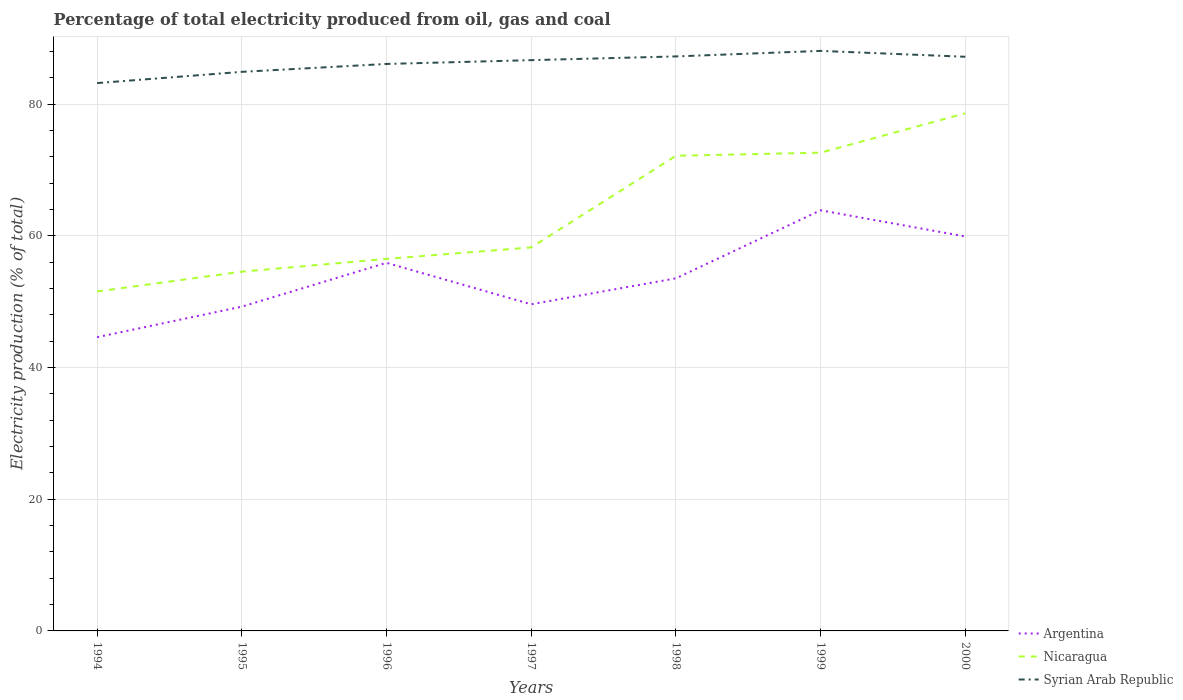How many different coloured lines are there?
Your answer should be compact. 3. Does the line corresponding to Syrian Arab Republic intersect with the line corresponding to Nicaragua?
Your response must be concise. No. Across all years, what is the maximum electricity production in in Nicaragua?
Provide a short and direct response. 51.55. What is the total electricity production in in Argentina in the graph?
Make the answer very short. 6.29. What is the difference between the highest and the second highest electricity production in in Argentina?
Provide a succinct answer. 19.27. Where does the legend appear in the graph?
Keep it short and to the point. Bottom right. How many legend labels are there?
Make the answer very short. 3. What is the title of the graph?
Provide a succinct answer. Percentage of total electricity produced from oil, gas and coal. Does "Other small states" appear as one of the legend labels in the graph?
Provide a succinct answer. No. What is the label or title of the Y-axis?
Ensure brevity in your answer.  Electricity production (% of total). What is the Electricity production (% of total) of Argentina in 1994?
Offer a terse response. 44.6. What is the Electricity production (% of total) in Nicaragua in 1994?
Keep it short and to the point. 51.55. What is the Electricity production (% of total) in Syrian Arab Republic in 1994?
Give a very brief answer. 83.19. What is the Electricity production (% of total) in Argentina in 1995?
Your answer should be compact. 49.24. What is the Electricity production (% of total) in Nicaragua in 1995?
Offer a terse response. 54.56. What is the Electricity production (% of total) of Syrian Arab Republic in 1995?
Ensure brevity in your answer.  84.9. What is the Electricity production (% of total) in Argentina in 1996?
Your response must be concise. 55.9. What is the Electricity production (% of total) in Nicaragua in 1996?
Offer a terse response. 56.5. What is the Electricity production (% of total) in Syrian Arab Republic in 1996?
Your response must be concise. 86.1. What is the Electricity production (% of total) in Argentina in 1997?
Offer a terse response. 49.6. What is the Electricity production (% of total) of Nicaragua in 1997?
Keep it short and to the point. 58.24. What is the Electricity production (% of total) of Syrian Arab Republic in 1997?
Offer a terse response. 86.67. What is the Electricity production (% of total) of Argentina in 1998?
Ensure brevity in your answer.  53.54. What is the Electricity production (% of total) in Nicaragua in 1998?
Make the answer very short. 72.15. What is the Electricity production (% of total) of Syrian Arab Republic in 1998?
Provide a short and direct response. 87.24. What is the Electricity production (% of total) of Argentina in 1999?
Offer a terse response. 63.87. What is the Electricity production (% of total) in Nicaragua in 1999?
Offer a terse response. 72.62. What is the Electricity production (% of total) of Syrian Arab Republic in 1999?
Offer a terse response. 88.08. What is the Electricity production (% of total) of Argentina in 2000?
Offer a terse response. 59.89. What is the Electricity production (% of total) in Nicaragua in 2000?
Your answer should be very brief. 78.6. What is the Electricity production (% of total) of Syrian Arab Republic in 2000?
Ensure brevity in your answer.  87.19. Across all years, what is the maximum Electricity production (% of total) in Argentina?
Give a very brief answer. 63.87. Across all years, what is the maximum Electricity production (% of total) of Nicaragua?
Provide a succinct answer. 78.6. Across all years, what is the maximum Electricity production (% of total) in Syrian Arab Republic?
Provide a short and direct response. 88.08. Across all years, what is the minimum Electricity production (% of total) of Argentina?
Your answer should be compact. 44.6. Across all years, what is the minimum Electricity production (% of total) in Nicaragua?
Provide a short and direct response. 51.55. Across all years, what is the minimum Electricity production (% of total) of Syrian Arab Republic?
Keep it short and to the point. 83.19. What is the total Electricity production (% of total) of Argentina in the graph?
Make the answer very short. 376.65. What is the total Electricity production (% of total) of Nicaragua in the graph?
Your answer should be very brief. 444.22. What is the total Electricity production (% of total) in Syrian Arab Republic in the graph?
Your response must be concise. 603.37. What is the difference between the Electricity production (% of total) of Argentina in 1994 and that in 1995?
Your answer should be compact. -4.64. What is the difference between the Electricity production (% of total) of Nicaragua in 1994 and that in 1995?
Provide a succinct answer. -3.01. What is the difference between the Electricity production (% of total) in Syrian Arab Republic in 1994 and that in 1995?
Provide a succinct answer. -1.71. What is the difference between the Electricity production (% of total) of Argentina in 1994 and that in 1996?
Offer a very short reply. -11.29. What is the difference between the Electricity production (% of total) of Nicaragua in 1994 and that in 1996?
Your answer should be very brief. -4.95. What is the difference between the Electricity production (% of total) in Syrian Arab Republic in 1994 and that in 1996?
Your answer should be compact. -2.91. What is the difference between the Electricity production (% of total) of Argentina in 1994 and that in 1997?
Your answer should be very brief. -5. What is the difference between the Electricity production (% of total) of Nicaragua in 1994 and that in 1997?
Make the answer very short. -6.69. What is the difference between the Electricity production (% of total) in Syrian Arab Republic in 1994 and that in 1997?
Your answer should be very brief. -3.48. What is the difference between the Electricity production (% of total) in Argentina in 1994 and that in 1998?
Your answer should be very brief. -8.94. What is the difference between the Electricity production (% of total) in Nicaragua in 1994 and that in 1998?
Your answer should be very brief. -20.61. What is the difference between the Electricity production (% of total) of Syrian Arab Republic in 1994 and that in 1998?
Make the answer very short. -4.05. What is the difference between the Electricity production (% of total) in Argentina in 1994 and that in 1999?
Ensure brevity in your answer.  -19.27. What is the difference between the Electricity production (% of total) in Nicaragua in 1994 and that in 1999?
Your answer should be very brief. -21.08. What is the difference between the Electricity production (% of total) of Syrian Arab Republic in 1994 and that in 1999?
Keep it short and to the point. -4.89. What is the difference between the Electricity production (% of total) of Argentina in 1994 and that in 2000?
Your answer should be very brief. -15.29. What is the difference between the Electricity production (% of total) in Nicaragua in 1994 and that in 2000?
Provide a succinct answer. -27.06. What is the difference between the Electricity production (% of total) of Syrian Arab Republic in 1994 and that in 2000?
Offer a very short reply. -4. What is the difference between the Electricity production (% of total) in Argentina in 1995 and that in 1996?
Offer a terse response. -6.65. What is the difference between the Electricity production (% of total) in Nicaragua in 1995 and that in 1996?
Your answer should be very brief. -1.94. What is the difference between the Electricity production (% of total) of Syrian Arab Republic in 1995 and that in 1996?
Make the answer very short. -1.2. What is the difference between the Electricity production (% of total) in Argentina in 1995 and that in 1997?
Ensure brevity in your answer.  -0.36. What is the difference between the Electricity production (% of total) of Nicaragua in 1995 and that in 1997?
Make the answer very short. -3.68. What is the difference between the Electricity production (% of total) in Syrian Arab Republic in 1995 and that in 1997?
Provide a succinct answer. -1.78. What is the difference between the Electricity production (% of total) of Argentina in 1995 and that in 1998?
Your answer should be compact. -4.3. What is the difference between the Electricity production (% of total) of Nicaragua in 1995 and that in 1998?
Offer a very short reply. -17.6. What is the difference between the Electricity production (% of total) of Syrian Arab Republic in 1995 and that in 1998?
Keep it short and to the point. -2.34. What is the difference between the Electricity production (% of total) of Argentina in 1995 and that in 1999?
Provide a short and direct response. -14.63. What is the difference between the Electricity production (% of total) in Nicaragua in 1995 and that in 1999?
Your answer should be compact. -18.07. What is the difference between the Electricity production (% of total) in Syrian Arab Republic in 1995 and that in 1999?
Offer a very short reply. -3.18. What is the difference between the Electricity production (% of total) of Argentina in 1995 and that in 2000?
Make the answer very short. -10.65. What is the difference between the Electricity production (% of total) of Nicaragua in 1995 and that in 2000?
Your answer should be very brief. -24.05. What is the difference between the Electricity production (% of total) in Syrian Arab Republic in 1995 and that in 2000?
Give a very brief answer. -2.29. What is the difference between the Electricity production (% of total) in Argentina in 1996 and that in 1997?
Your answer should be compact. 6.29. What is the difference between the Electricity production (% of total) of Nicaragua in 1996 and that in 1997?
Offer a terse response. -1.74. What is the difference between the Electricity production (% of total) in Syrian Arab Republic in 1996 and that in 1997?
Your answer should be very brief. -0.58. What is the difference between the Electricity production (% of total) of Argentina in 1996 and that in 1998?
Provide a succinct answer. 2.36. What is the difference between the Electricity production (% of total) in Nicaragua in 1996 and that in 1998?
Offer a terse response. -15.66. What is the difference between the Electricity production (% of total) of Syrian Arab Republic in 1996 and that in 1998?
Keep it short and to the point. -1.14. What is the difference between the Electricity production (% of total) in Argentina in 1996 and that in 1999?
Ensure brevity in your answer.  -7.98. What is the difference between the Electricity production (% of total) in Nicaragua in 1996 and that in 1999?
Ensure brevity in your answer.  -16.12. What is the difference between the Electricity production (% of total) of Syrian Arab Republic in 1996 and that in 1999?
Give a very brief answer. -1.98. What is the difference between the Electricity production (% of total) of Argentina in 1996 and that in 2000?
Offer a very short reply. -4. What is the difference between the Electricity production (% of total) of Nicaragua in 1996 and that in 2000?
Your answer should be compact. -22.11. What is the difference between the Electricity production (% of total) of Syrian Arab Republic in 1996 and that in 2000?
Give a very brief answer. -1.09. What is the difference between the Electricity production (% of total) in Argentina in 1997 and that in 1998?
Make the answer very short. -3.94. What is the difference between the Electricity production (% of total) of Nicaragua in 1997 and that in 1998?
Ensure brevity in your answer.  -13.91. What is the difference between the Electricity production (% of total) of Syrian Arab Republic in 1997 and that in 1998?
Your answer should be compact. -0.56. What is the difference between the Electricity production (% of total) in Argentina in 1997 and that in 1999?
Ensure brevity in your answer.  -14.27. What is the difference between the Electricity production (% of total) of Nicaragua in 1997 and that in 1999?
Provide a short and direct response. -14.38. What is the difference between the Electricity production (% of total) in Syrian Arab Republic in 1997 and that in 1999?
Keep it short and to the point. -1.41. What is the difference between the Electricity production (% of total) of Argentina in 1997 and that in 2000?
Your answer should be very brief. -10.29. What is the difference between the Electricity production (% of total) in Nicaragua in 1997 and that in 2000?
Your answer should be very brief. -20.37. What is the difference between the Electricity production (% of total) of Syrian Arab Republic in 1997 and that in 2000?
Give a very brief answer. -0.51. What is the difference between the Electricity production (% of total) in Argentina in 1998 and that in 1999?
Offer a terse response. -10.33. What is the difference between the Electricity production (% of total) in Nicaragua in 1998 and that in 1999?
Give a very brief answer. -0.47. What is the difference between the Electricity production (% of total) in Syrian Arab Republic in 1998 and that in 1999?
Ensure brevity in your answer.  -0.84. What is the difference between the Electricity production (% of total) of Argentina in 1998 and that in 2000?
Your response must be concise. -6.35. What is the difference between the Electricity production (% of total) of Nicaragua in 1998 and that in 2000?
Offer a very short reply. -6.45. What is the difference between the Electricity production (% of total) of Syrian Arab Republic in 1998 and that in 2000?
Provide a short and direct response. 0.05. What is the difference between the Electricity production (% of total) in Argentina in 1999 and that in 2000?
Ensure brevity in your answer.  3.98. What is the difference between the Electricity production (% of total) in Nicaragua in 1999 and that in 2000?
Your answer should be very brief. -5.98. What is the difference between the Electricity production (% of total) of Syrian Arab Republic in 1999 and that in 2000?
Your answer should be compact. 0.89. What is the difference between the Electricity production (% of total) of Argentina in 1994 and the Electricity production (% of total) of Nicaragua in 1995?
Offer a terse response. -9.95. What is the difference between the Electricity production (% of total) of Argentina in 1994 and the Electricity production (% of total) of Syrian Arab Republic in 1995?
Provide a succinct answer. -40.3. What is the difference between the Electricity production (% of total) of Nicaragua in 1994 and the Electricity production (% of total) of Syrian Arab Republic in 1995?
Provide a succinct answer. -33.35. What is the difference between the Electricity production (% of total) of Argentina in 1994 and the Electricity production (% of total) of Nicaragua in 1996?
Offer a terse response. -11.9. What is the difference between the Electricity production (% of total) of Argentina in 1994 and the Electricity production (% of total) of Syrian Arab Republic in 1996?
Make the answer very short. -41.49. What is the difference between the Electricity production (% of total) of Nicaragua in 1994 and the Electricity production (% of total) of Syrian Arab Republic in 1996?
Your response must be concise. -34.55. What is the difference between the Electricity production (% of total) in Argentina in 1994 and the Electricity production (% of total) in Nicaragua in 1997?
Your response must be concise. -13.64. What is the difference between the Electricity production (% of total) of Argentina in 1994 and the Electricity production (% of total) of Syrian Arab Republic in 1997?
Provide a succinct answer. -42.07. What is the difference between the Electricity production (% of total) of Nicaragua in 1994 and the Electricity production (% of total) of Syrian Arab Republic in 1997?
Keep it short and to the point. -35.13. What is the difference between the Electricity production (% of total) of Argentina in 1994 and the Electricity production (% of total) of Nicaragua in 1998?
Your answer should be compact. -27.55. What is the difference between the Electricity production (% of total) of Argentina in 1994 and the Electricity production (% of total) of Syrian Arab Republic in 1998?
Give a very brief answer. -42.64. What is the difference between the Electricity production (% of total) in Nicaragua in 1994 and the Electricity production (% of total) in Syrian Arab Republic in 1998?
Ensure brevity in your answer.  -35.69. What is the difference between the Electricity production (% of total) of Argentina in 1994 and the Electricity production (% of total) of Nicaragua in 1999?
Offer a terse response. -28.02. What is the difference between the Electricity production (% of total) of Argentina in 1994 and the Electricity production (% of total) of Syrian Arab Republic in 1999?
Provide a succinct answer. -43.48. What is the difference between the Electricity production (% of total) in Nicaragua in 1994 and the Electricity production (% of total) in Syrian Arab Republic in 1999?
Provide a short and direct response. -36.53. What is the difference between the Electricity production (% of total) of Argentina in 1994 and the Electricity production (% of total) of Nicaragua in 2000?
Give a very brief answer. -34. What is the difference between the Electricity production (% of total) of Argentina in 1994 and the Electricity production (% of total) of Syrian Arab Republic in 2000?
Keep it short and to the point. -42.58. What is the difference between the Electricity production (% of total) in Nicaragua in 1994 and the Electricity production (% of total) in Syrian Arab Republic in 2000?
Your response must be concise. -35.64. What is the difference between the Electricity production (% of total) in Argentina in 1995 and the Electricity production (% of total) in Nicaragua in 1996?
Your response must be concise. -7.25. What is the difference between the Electricity production (% of total) in Argentina in 1995 and the Electricity production (% of total) in Syrian Arab Republic in 1996?
Your response must be concise. -36.85. What is the difference between the Electricity production (% of total) in Nicaragua in 1995 and the Electricity production (% of total) in Syrian Arab Republic in 1996?
Your response must be concise. -31.54. What is the difference between the Electricity production (% of total) of Argentina in 1995 and the Electricity production (% of total) of Nicaragua in 1997?
Offer a very short reply. -9. What is the difference between the Electricity production (% of total) in Argentina in 1995 and the Electricity production (% of total) in Syrian Arab Republic in 1997?
Make the answer very short. -37.43. What is the difference between the Electricity production (% of total) of Nicaragua in 1995 and the Electricity production (% of total) of Syrian Arab Republic in 1997?
Your response must be concise. -32.12. What is the difference between the Electricity production (% of total) of Argentina in 1995 and the Electricity production (% of total) of Nicaragua in 1998?
Your response must be concise. -22.91. What is the difference between the Electricity production (% of total) in Argentina in 1995 and the Electricity production (% of total) in Syrian Arab Republic in 1998?
Offer a terse response. -38. What is the difference between the Electricity production (% of total) of Nicaragua in 1995 and the Electricity production (% of total) of Syrian Arab Republic in 1998?
Provide a succinct answer. -32.68. What is the difference between the Electricity production (% of total) in Argentina in 1995 and the Electricity production (% of total) in Nicaragua in 1999?
Your response must be concise. -23.38. What is the difference between the Electricity production (% of total) of Argentina in 1995 and the Electricity production (% of total) of Syrian Arab Republic in 1999?
Keep it short and to the point. -38.84. What is the difference between the Electricity production (% of total) in Nicaragua in 1995 and the Electricity production (% of total) in Syrian Arab Republic in 1999?
Your answer should be compact. -33.52. What is the difference between the Electricity production (% of total) in Argentina in 1995 and the Electricity production (% of total) in Nicaragua in 2000?
Offer a very short reply. -29.36. What is the difference between the Electricity production (% of total) in Argentina in 1995 and the Electricity production (% of total) in Syrian Arab Republic in 2000?
Your response must be concise. -37.94. What is the difference between the Electricity production (% of total) in Nicaragua in 1995 and the Electricity production (% of total) in Syrian Arab Republic in 2000?
Offer a terse response. -32.63. What is the difference between the Electricity production (% of total) in Argentina in 1996 and the Electricity production (% of total) in Nicaragua in 1997?
Keep it short and to the point. -2.34. What is the difference between the Electricity production (% of total) in Argentina in 1996 and the Electricity production (% of total) in Syrian Arab Republic in 1997?
Ensure brevity in your answer.  -30.78. What is the difference between the Electricity production (% of total) of Nicaragua in 1996 and the Electricity production (% of total) of Syrian Arab Republic in 1997?
Make the answer very short. -30.18. What is the difference between the Electricity production (% of total) in Argentina in 1996 and the Electricity production (% of total) in Nicaragua in 1998?
Provide a succinct answer. -16.26. What is the difference between the Electricity production (% of total) of Argentina in 1996 and the Electricity production (% of total) of Syrian Arab Republic in 1998?
Offer a terse response. -31.34. What is the difference between the Electricity production (% of total) of Nicaragua in 1996 and the Electricity production (% of total) of Syrian Arab Republic in 1998?
Make the answer very short. -30.74. What is the difference between the Electricity production (% of total) of Argentina in 1996 and the Electricity production (% of total) of Nicaragua in 1999?
Offer a terse response. -16.73. What is the difference between the Electricity production (% of total) of Argentina in 1996 and the Electricity production (% of total) of Syrian Arab Republic in 1999?
Keep it short and to the point. -32.18. What is the difference between the Electricity production (% of total) in Nicaragua in 1996 and the Electricity production (% of total) in Syrian Arab Republic in 1999?
Your response must be concise. -31.58. What is the difference between the Electricity production (% of total) of Argentina in 1996 and the Electricity production (% of total) of Nicaragua in 2000?
Your answer should be compact. -22.71. What is the difference between the Electricity production (% of total) of Argentina in 1996 and the Electricity production (% of total) of Syrian Arab Republic in 2000?
Provide a succinct answer. -31.29. What is the difference between the Electricity production (% of total) in Nicaragua in 1996 and the Electricity production (% of total) in Syrian Arab Republic in 2000?
Provide a succinct answer. -30.69. What is the difference between the Electricity production (% of total) of Argentina in 1997 and the Electricity production (% of total) of Nicaragua in 1998?
Ensure brevity in your answer.  -22.55. What is the difference between the Electricity production (% of total) in Argentina in 1997 and the Electricity production (% of total) in Syrian Arab Republic in 1998?
Give a very brief answer. -37.64. What is the difference between the Electricity production (% of total) in Nicaragua in 1997 and the Electricity production (% of total) in Syrian Arab Republic in 1998?
Your answer should be very brief. -29. What is the difference between the Electricity production (% of total) of Argentina in 1997 and the Electricity production (% of total) of Nicaragua in 1999?
Make the answer very short. -23.02. What is the difference between the Electricity production (% of total) of Argentina in 1997 and the Electricity production (% of total) of Syrian Arab Republic in 1999?
Provide a succinct answer. -38.48. What is the difference between the Electricity production (% of total) of Nicaragua in 1997 and the Electricity production (% of total) of Syrian Arab Republic in 1999?
Ensure brevity in your answer.  -29.84. What is the difference between the Electricity production (% of total) in Argentina in 1997 and the Electricity production (% of total) in Nicaragua in 2000?
Ensure brevity in your answer.  -29. What is the difference between the Electricity production (% of total) in Argentina in 1997 and the Electricity production (% of total) in Syrian Arab Republic in 2000?
Give a very brief answer. -37.59. What is the difference between the Electricity production (% of total) in Nicaragua in 1997 and the Electricity production (% of total) in Syrian Arab Republic in 2000?
Your response must be concise. -28.95. What is the difference between the Electricity production (% of total) in Argentina in 1998 and the Electricity production (% of total) in Nicaragua in 1999?
Your answer should be very brief. -19.08. What is the difference between the Electricity production (% of total) of Argentina in 1998 and the Electricity production (% of total) of Syrian Arab Republic in 1999?
Make the answer very short. -34.54. What is the difference between the Electricity production (% of total) of Nicaragua in 1998 and the Electricity production (% of total) of Syrian Arab Republic in 1999?
Provide a succinct answer. -15.93. What is the difference between the Electricity production (% of total) in Argentina in 1998 and the Electricity production (% of total) in Nicaragua in 2000?
Your answer should be compact. -25.06. What is the difference between the Electricity production (% of total) in Argentina in 1998 and the Electricity production (% of total) in Syrian Arab Republic in 2000?
Your answer should be compact. -33.65. What is the difference between the Electricity production (% of total) in Nicaragua in 1998 and the Electricity production (% of total) in Syrian Arab Republic in 2000?
Your response must be concise. -15.03. What is the difference between the Electricity production (% of total) in Argentina in 1999 and the Electricity production (% of total) in Nicaragua in 2000?
Offer a very short reply. -14.73. What is the difference between the Electricity production (% of total) of Argentina in 1999 and the Electricity production (% of total) of Syrian Arab Republic in 2000?
Make the answer very short. -23.31. What is the difference between the Electricity production (% of total) of Nicaragua in 1999 and the Electricity production (% of total) of Syrian Arab Republic in 2000?
Offer a terse response. -14.56. What is the average Electricity production (% of total) of Argentina per year?
Keep it short and to the point. 53.81. What is the average Electricity production (% of total) of Nicaragua per year?
Provide a short and direct response. 63.46. What is the average Electricity production (% of total) of Syrian Arab Republic per year?
Ensure brevity in your answer.  86.2. In the year 1994, what is the difference between the Electricity production (% of total) in Argentina and Electricity production (% of total) in Nicaragua?
Ensure brevity in your answer.  -6.94. In the year 1994, what is the difference between the Electricity production (% of total) in Argentina and Electricity production (% of total) in Syrian Arab Republic?
Your answer should be very brief. -38.59. In the year 1994, what is the difference between the Electricity production (% of total) of Nicaragua and Electricity production (% of total) of Syrian Arab Republic?
Make the answer very short. -31.64. In the year 1995, what is the difference between the Electricity production (% of total) of Argentina and Electricity production (% of total) of Nicaragua?
Make the answer very short. -5.31. In the year 1995, what is the difference between the Electricity production (% of total) in Argentina and Electricity production (% of total) in Syrian Arab Republic?
Your response must be concise. -35.66. In the year 1995, what is the difference between the Electricity production (% of total) of Nicaragua and Electricity production (% of total) of Syrian Arab Republic?
Ensure brevity in your answer.  -30.34. In the year 1996, what is the difference between the Electricity production (% of total) in Argentina and Electricity production (% of total) in Nicaragua?
Make the answer very short. -0.6. In the year 1996, what is the difference between the Electricity production (% of total) of Argentina and Electricity production (% of total) of Syrian Arab Republic?
Your response must be concise. -30.2. In the year 1996, what is the difference between the Electricity production (% of total) in Nicaragua and Electricity production (% of total) in Syrian Arab Republic?
Make the answer very short. -29.6. In the year 1997, what is the difference between the Electricity production (% of total) of Argentina and Electricity production (% of total) of Nicaragua?
Provide a short and direct response. -8.64. In the year 1997, what is the difference between the Electricity production (% of total) of Argentina and Electricity production (% of total) of Syrian Arab Republic?
Offer a very short reply. -37.07. In the year 1997, what is the difference between the Electricity production (% of total) in Nicaragua and Electricity production (% of total) in Syrian Arab Republic?
Make the answer very short. -28.44. In the year 1998, what is the difference between the Electricity production (% of total) in Argentina and Electricity production (% of total) in Nicaragua?
Offer a very short reply. -18.61. In the year 1998, what is the difference between the Electricity production (% of total) of Argentina and Electricity production (% of total) of Syrian Arab Republic?
Offer a terse response. -33.7. In the year 1998, what is the difference between the Electricity production (% of total) in Nicaragua and Electricity production (% of total) in Syrian Arab Republic?
Provide a succinct answer. -15.09. In the year 1999, what is the difference between the Electricity production (% of total) in Argentina and Electricity production (% of total) in Nicaragua?
Offer a very short reply. -8.75. In the year 1999, what is the difference between the Electricity production (% of total) of Argentina and Electricity production (% of total) of Syrian Arab Republic?
Offer a terse response. -24.21. In the year 1999, what is the difference between the Electricity production (% of total) in Nicaragua and Electricity production (% of total) in Syrian Arab Republic?
Provide a succinct answer. -15.46. In the year 2000, what is the difference between the Electricity production (% of total) in Argentina and Electricity production (% of total) in Nicaragua?
Give a very brief answer. -18.71. In the year 2000, what is the difference between the Electricity production (% of total) in Argentina and Electricity production (% of total) in Syrian Arab Republic?
Your answer should be compact. -27.29. In the year 2000, what is the difference between the Electricity production (% of total) of Nicaragua and Electricity production (% of total) of Syrian Arab Republic?
Offer a very short reply. -8.58. What is the ratio of the Electricity production (% of total) in Argentina in 1994 to that in 1995?
Provide a short and direct response. 0.91. What is the ratio of the Electricity production (% of total) of Nicaragua in 1994 to that in 1995?
Offer a terse response. 0.94. What is the ratio of the Electricity production (% of total) of Syrian Arab Republic in 1994 to that in 1995?
Your answer should be very brief. 0.98. What is the ratio of the Electricity production (% of total) in Argentina in 1994 to that in 1996?
Give a very brief answer. 0.8. What is the ratio of the Electricity production (% of total) of Nicaragua in 1994 to that in 1996?
Keep it short and to the point. 0.91. What is the ratio of the Electricity production (% of total) of Syrian Arab Republic in 1994 to that in 1996?
Your response must be concise. 0.97. What is the ratio of the Electricity production (% of total) of Argentina in 1994 to that in 1997?
Your response must be concise. 0.9. What is the ratio of the Electricity production (% of total) of Nicaragua in 1994 to that in 1997?
Make the answer very short. 0.89. What is the ratio of the Electricity production (% of total) in Syrian Arab Republic in 1994 to that in 1997?
Your response must be concise. 0.96. What is the ratio of the Electricity production (% of total) of Argentina in 1994 to that in 1998?
Keep it short and to the point. 0.83. What is the ratio of the Electricity production (% of total) of Nicaragua in 1994 to that in 1998?
Your answer should be very brief. 0.71. What is the ratio of the Electricity production (% of total) in Syrian Arab Republic in 1994 to that in 1998?
Your answer should be compact. 0.95. What is the ratio of the Electricity production (% of total) of Argentina in 1994 to that in 1999?
Your answer should be very brief. 0.7. What is the ratio of the Electricity production (% of total) in Nicaragua in 1994 to that in 1999?
Give a very brief answer. 0.71. What is the ratio of the Electricity production (% of total) in Syrian Arab Republic in 1994 to that in 1999?
Give a very brief answer. 0.94. What is the ratio of the Electricity production (% of total) of Argentina in 1994 to that in 2000?
Ensure brevity in your answer.  0.74. What is the ratio of the Electricity production (% of total) in Nicaragua in 1994 to that in 2000?
Make the answer very short. 0.66. What is the ratio of the Electricity production (% of total) in Syrian Arab Republic in 1994 to that in 2000?
Your answer should be compact. 0.95. What is the ratio of the Electricity production (% of total) in Argentina in 1995 to that in 1996?
Your answer should be very brief. 0.88. What is the ratio of the Electricity production (% of total) of Nicaragua in 1995 to that in 1996?
Provide a succinct answer. 0.97. What is the ratio of the Electricity production (% of total) in Syrian Arab Republic in 1995 to that in 1996?
Ensure brevity in your answer.  0.99. What is the ratio of the Electricity production (% of total) of Argentina in 1995 to that in 1997?
Keep it short and to the point. 0.99. What is the ratio of the Electricity production (% of total) of Nicaragua in 1995 to that in 1997?
Offer a very short reply. 0.94. What is the ratio of the Electricity production (% of total) of Syrian Arab Republic in 1995 to that in 1997?
Your response must be concise. 0.98. What is the ratio of the Electricity production (% of total) of Argentina in 1995 to that in 1998?
Your answer should be compact. 0.92. What is the ratio of the Electricity production (% of total) in Nicaragua in 1995 to that in 1998?
Offer a terse response. 0.76. What is the ratio of the Electricity production (% of total) in Syrian Arab Republic in 1995 to that in 1998?
Provide a short and direct response. 0.97. What is the ratio of the Electricity production (% of total) of Argentina in 1995 to that in 1999?
Your answer should be very brief. 0.77. What is the ratio of the Electricity production (% of total) of Nicaragua in 1995 to that in 1999?
Provide a succinct answer. 0.75. What is the ratio of the Electricity production (% of total) in Syrian Arab Republic in 1995 to that in 1999?
Ensure brevity in your answer.  0.96. What is the ratio of the Electricity production (% of total) in Argentina in 1995 to that in 2000?
Your answer should be compact. 0.82. What is the ratio of the Electricity production (% of total) in Nicaragua in 1995 to that in 2000?
Provide a succinct answer. 0.69. What is the ratio of the Electricity production (% of total) in Syrian Arab Republic in 1995 to that in 2000?
Ensure brevity in your answer.  0.97. What is the ratio of the Electricity production (% of total) of Argentina in 1996 to that in 1997?
Your response must be concise. 1.13. What is the ratio of the Electricity production (% of total) in Nicaragua in 1996 to that in 1997?
Offer a very short reply. 0.97. What is the ratio of the Electricity production (% of total) in Syrian Arab Republic in 1996 to that in 1997?
Offer a very short reply. 0.99. What is the ratio of the Electricity production (% of total) of Argentina in 1996 to that in 1998?
Ensure brevity in your answer.  1.04. What is the ratio of the Electricity production (% of total) of Nicaragua in 1996 to that in 1998?
Provide a succinct answer. 0.78. What is the ratio of the Electricity production (% of total) of Syrian Arab Republic in 1996 to that in 1998?
Offer a terse response. 0.99. What is the ratio of the Electricity production (% of total) in Argentina in 1996 to that in 1999?
Your answer should be very brief. 0.88. What is the ratio of the Electricity production (% of total) of Nicaragua in 1996 to that in 1999?
Give a very brief answer. 0.78. What is the ratio of the Electricity production (% of total) of Syrian Arab Republic in 1996 to that in 1999?
Keep it short and to the point. 0.98. What is the ratio of the Electricity production (% of total) in Argentina in 1996 to that in 2000?
Offer a very short reply. 0.93. What is the ratio of the Electricity production (% of total) of Nicaragua in 1996 to that in 2000?
Give a very brief answer. 0.72. What is the ratio of the Electricity production (% of total) in Syrian Arab Republic in 1996 to that in 2000?
Offer a terse response. 0.99. What is the ratio of the Electricity production (% of total) of Argentina in 1997 to that in 1998?
Provide a succinct answer. 0.93. What is the ratio of the Electricity production (% of total) of Nicaragua in 1997 to that in 1998?
Offer a terse response. 0.81. What is the ratio of the Electricity production (% of total) of Syrian Arab Republic in 1997 to that in 1998?
Keep it short and to the point. 0.99. What is the ratio of the Electricity production (% of total) of Argentina in 1997 to that in 1999?
Ensure brevity in your answer.  0.78. What is the ratio of the Electricity production (% of total) in Nicaragua in 1997 to that in 1999?
Offer a terse response. 0.8. What is the ratio of the Electricity production (% of total) in Syrian Arab Republic in 1997 to that in 1999?
Your answer should be very brief. 0.98. What is the ratio of the Electricity production (% of total) in Argentina in 1997 to that in 2000?
Provide a succinct answer. 0.83. What is the ratio of the Electricity production (% of total) in Nicaragua in 1997 to that in 2000?
Your answer should be compact. 0.74. What is the ratio of the Electricity production (% of total) in Argentina in 1998 to that in 1999?
Your answer should be very brief. 0.84. What is the ratio of the Electricity production (% of total) of Argentina in 1998 to that in 2000?
Your answer should be compact. 0.89. What is the ratio of the Electricity production (% of total) in Nicaragua in 1998 to that in 2000?
Ensure brevity in your answer.  0.92. What is the ratio of the Electricity production (% of total) of Argentina in 1999 to that in 2000?
Give a very brief answer. 1.07. What is the ratio of the Electricity production (% of total) of Nicaragua in 1999 to that in 2000?
Provide a succinct answer. 0.92. What is the ratio of the Electricity production (% of total) of Syrian Arab Republic in 1999 to that in 2000?
Offer a very short reply. 1.01. What is the difference between the highest and the second highest Electricity production (% of total) of Argentina?
Ensure brevity in your answer.  3.98. What is the difference between the highest and the second highest Electricity production (% of total) in Nicaragua?
Provide a succinct answer. 5.98. What is the difference between the highest and the second highest Electricity production (% of total) of Syrian Arab Republic?
Ensure brevity in your answer.  0.84. What is the difference between the highest and the lowest Electricity production (% of total) of Argentina?
Offer a terse response. 19.27. What is the difference between the highest and the lowest Electricity production (% of total) in Nicaragua?
Provide a short and direct response. 27.06. What is the difference between the highest and the lowest Electricity production (% of total) in Syrian Arab Republic?
Offer a terse response. 4.89. 